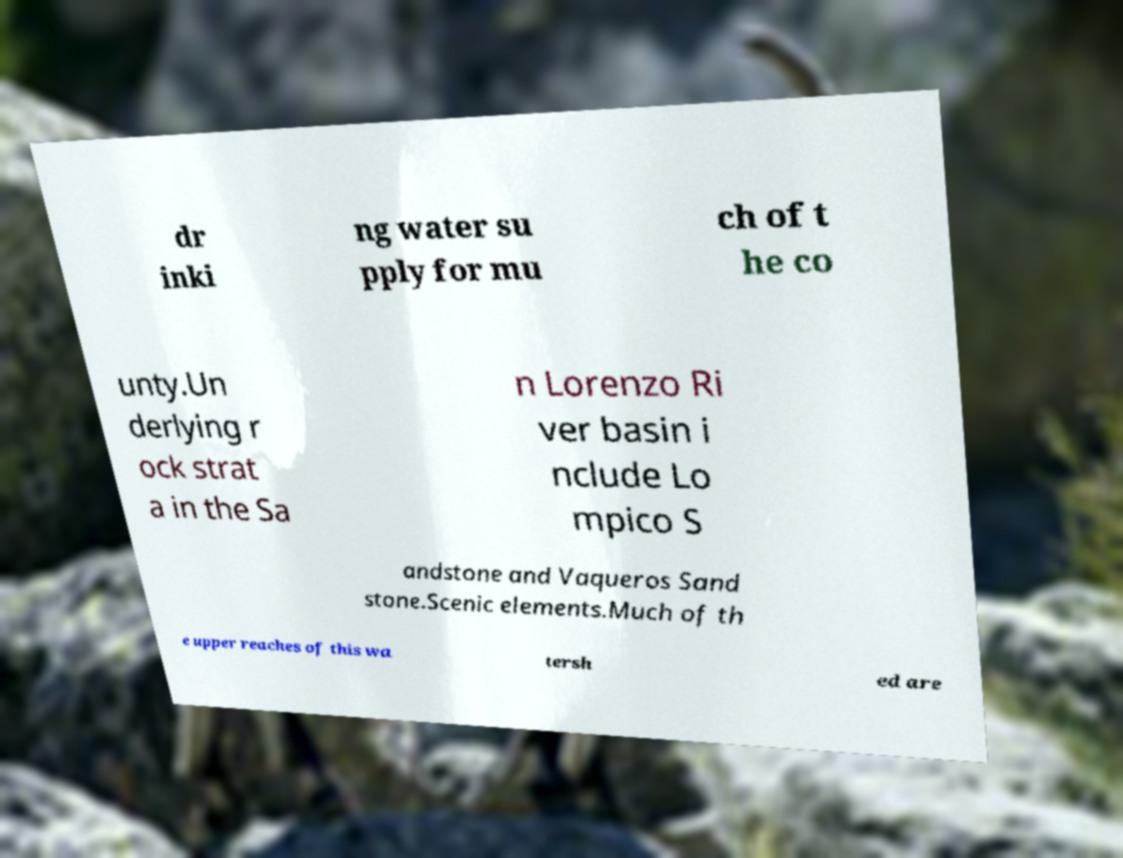What messages or text are displayed in this image? I need them in a readable, typed format. dr inki ng water su pply for mu ch of t he co unty.Un derlying r ock strat a in the Sa n Lorenzo Ri ver basin i nclude Lo mpico S andstone and Vaqueros Sand stone.Scenic elements.Much of th e upper reaches of this wa tersh ed are 